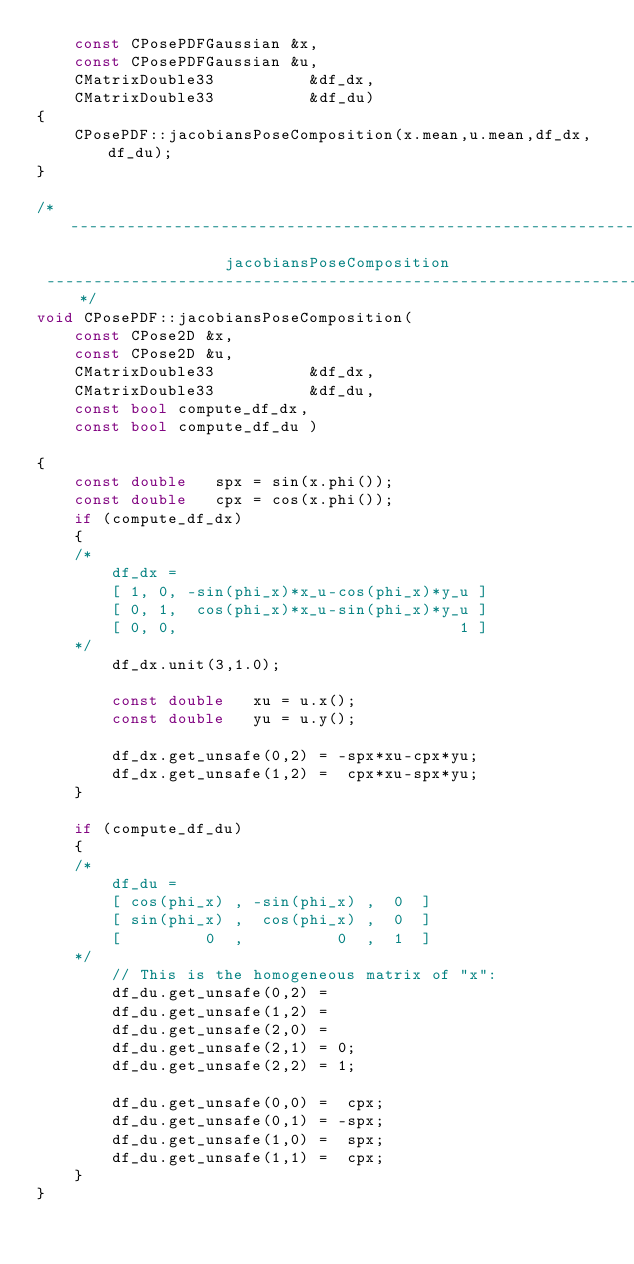<code> <loc_0><loc_0><loc_500><loc_500><_C++_>	const CPosePDFGaussian &x,
	const CPosePDFGaussian &u,
	CMatrixDouble33			 &df_dx,
	CMatrixDouble33			 &df_du)
{
	CPosePDF::jacobiansPoseComposition(x.mean,u.mean,df_dx,df_du);
}

/*---------------------------------------------------------------
					jacobiansPoseComposition
 ---------------------------------------------------------------*/
void CPosePDF::jacobiansPoseComposition(
	const CPose2D &x,
	const CPose2D &u,
	CMatrixDouble33			 &df_dx,
	CMatrixDouble33			 &df_du,
	const bool compute_df_dx,
	const bool compute_df_du )

{
	const double   spx = sin(x.phi());
	const double   cpx = cos(x.phi());
	if (compute_df_dx)
	{
	/*
		df_dx =
		[ 1, 0, -sin(phi_x)*x_u-cos(phi_x)*y_u ]
		[ 0, 1,  cos(phi_x)*x_u-sin(phi_x)*y_u ]
		[ 0, 0,                              1 ]
	*/
		df_dx.unit(3,1.0);

		const double   xu = u.x();
		const double   yu = u.y();

		df_dx.get_unsafe(0,2) = -spx*xu-cpx*yu;
		df_dx.get_unsafe(1,2) =  cpx*xu-spx*yu;
	}

	if (compute_df_du)
	{
	/*
		df_du =
		[ cos(phi_x) , -sin(phi_x) ,  0  ]
		[ sin(phi_x) ,  cos(phi_x) ,  0  ]
		[         0  ,          0  ,  1  ]
	*/
		// This is the homogeneous matrix of "x":
		df_du.get_unsafe(0,2) =
		df_du.get_unsafe(1,2) =
		df_du.get_unsafe(2,0) =
		df_du.get_unsafe(2,1) = 0;
		df_du.get_unsafe(2,2) = 1;

		df_du.get_unsafe(0,0) =  cpx;
		df_du.get_unsafe(0,1) = -spx;
		df_du.get_unsafe(1,0) =  spx;
		df_du.get_unsafe(1,1) =  cpx;
	}
}


</code> 